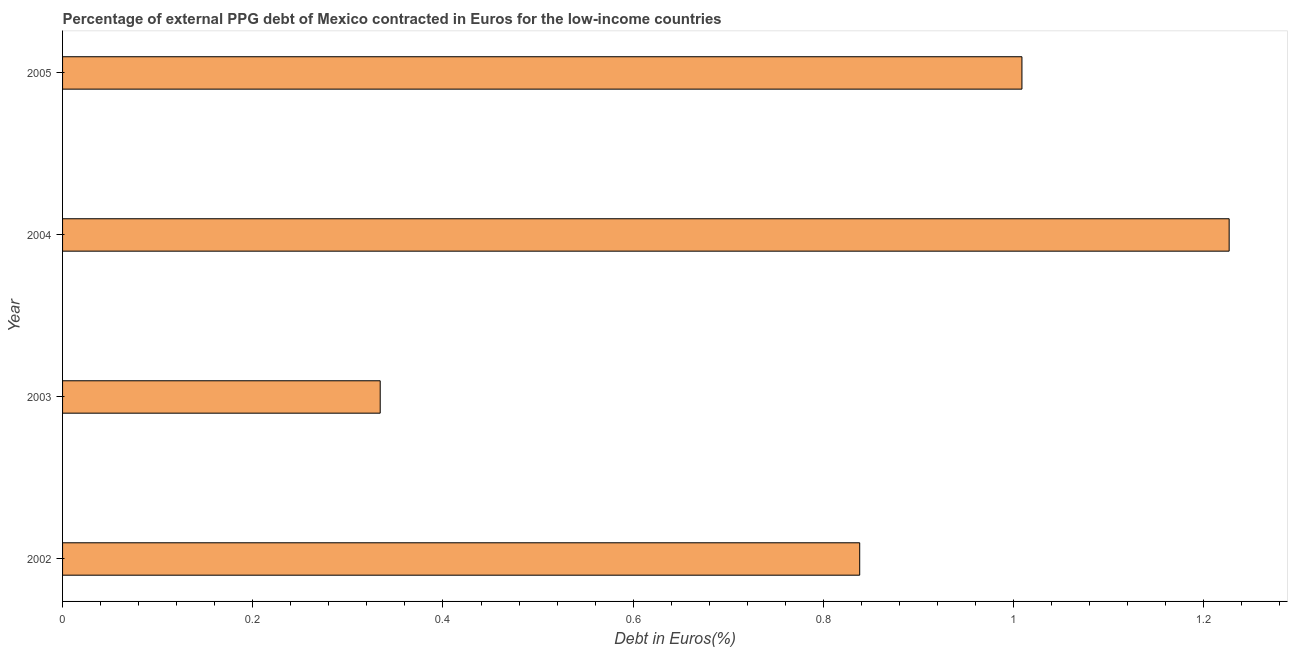Does the graph contain any zero values?
Ensure brevity in your answer.  No. What is the title of the graph?
Make the answer very short. Percentage of external PPG debt of Mexico contracted in Euros for the low-income countries. What is the label or title of the X-axis?
Ensure brevity in your answer.  Debt in Euros(%). What is the currency composition of ppg debt in 2002?
Offer a terse response. 0.84. Across all years, what is the maximum currency composition of ppg debt?
Offer a very short reply. 1.23. Across all years, what is the minimum currency composition of ppg debt?
Provide a succinct answer. 0.33. In which year was the currency composition of ppg debt maximum?
Your response must be concise. 2004. In which year was the currency composition of ppg debt minimum?
Your answer should be very brief. 2003. What is the sum of the currency composition of ppg debt?
Provide a short and direct response. 3.41. What is the difference between the currency composition of ppg debt in 2002 and 2004?
Offer a very short reply. -0.39. What is the average currency composition of ppg debt per year?
Make the answer very short. 0.85. What is the median currency composition of ppg debt?
Provide a short and direct response. 0.92. Do a majority of the years between 2003 and 2005 (inclusive) have currency composition of ppg debt greater than 0.28 %?
Keep it short and to the point. Yes. What is the ratio of the currency composition of ppg debt in 2002 to that in 2005?
Provide a short and direct response. 0.83. Is the currency composition of ppg debt in 2002 less than that in 2003?
Provide a succinct answer. No. What is the difference between the highest and the second highest currency composition of ppg debt?
Your answer should be compact. 0.22. Is the sum of the currency composition of ppg debt in 2002 and 2003 greater than the maximum currency composition of ppg debt across all years?
Your response must be concise. No. What is the difference between the highest and the lowest currency composition of ppg debt?
Your response must be concise. 0.89. How many bars are there?
Your answer should be very brief. 4. Are all the bars in the graph horizontal?
Your response must be concise. Yes. What is the difference between two consecutive major ticks on the X-axis?
Provide a short and direct response. 0.2. What is the Debt in Euros(%) in 2002?
Your answer should be very brief. 0.84. What is the Debt in Euros(%) in 2003?
Provide a short and direct response. 0.33. What is the Debt in Euros(%) in 2004?
Ensure brevity in your answer.  1.23. What is the Debt in Euros(%) in 2005?
Offer a terse response. 1.01. What is the difference between the Debt in Euros(%) in 2002 and 2003?
Make the answer very short. 0.5. What is the difference between the Debt in Euros(%) in 2002 and 2004?
Your response must be concise. -0.39. What is the difference between the Debt in Euros(%) in 2002 and 2005?
Make the answer very short. -0.17. What is the difference between the Debt in Euros(%) in 2003 and 2004?
Provide a short and direct response. -0.89. What is the difference between the Debt in Euros(%) in 2003 and 2005?
Provide a short and direct response. -0.67. What is the difference between the Debt in Euros(%) in 2004 and 2005?
Offer a very short reply. 0.22. What is the ratio of the Debt in Euros(%) in 2002 to that in 2003?
Give a very brief answer. 2.51. What is the ratio of the Debt in Euros(%) in 2002 to that in 2004?
Ensure brevity in your answer.  0.68. What is the ratio of the Debt in Euros(%) in 2002 to that in 2005?
Offer a terse response. 0.83. What is the ratio of the Debt in Euros(%) in 2003 to that in 2004?
Make the answer very short. 0.27. What is the ratio of the Debt in Euros(%) in 2003 to that in 2005?
Provide a short and direct response. 0.33. What is the ratio of the Debt in Euros(%) in 2004 to that in 2005?
Your answer should be very brief. 1.22. 